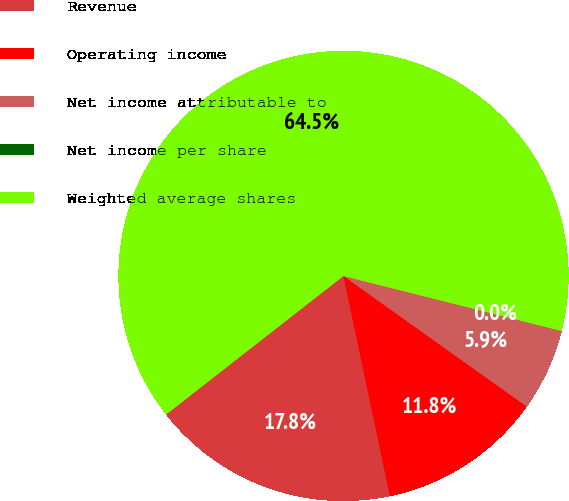<chart> <loc_0><loc_0><loc_500><loc_500><pie_chart><fcel>Revenue<fcel>Operating income<fcel>Net income attributable to<fcel>Net income per share<fcel>Weighted average shares<nl><fcel>17.76%<fcel>11.84%<fcel>5.92%<fcel>0.0%<fcel>64.48%<nl></chart> 